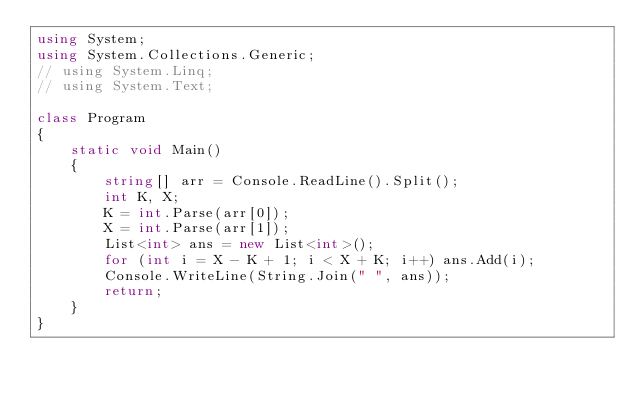<code> <loc_0><loc_0><loc_500><loc_500><_C#_>using System;
using System.Collections.Generic;
// using System.Linq;
// using System.Text;

class Program
{
    static void Main()
    {
        string[] arr = Console.ReadLine().Split();
        int K, X;
        K = int.Parse(arr[0]);
        X = int.Parse(arr[1]);
        List<int> ans = new List<int>();
        for (int i = X - K + 1; i < X + K; i++) ans.Add(i);
        Console.WriteLine(String.Join(" ", ans));
        return;
    }
}</code> 